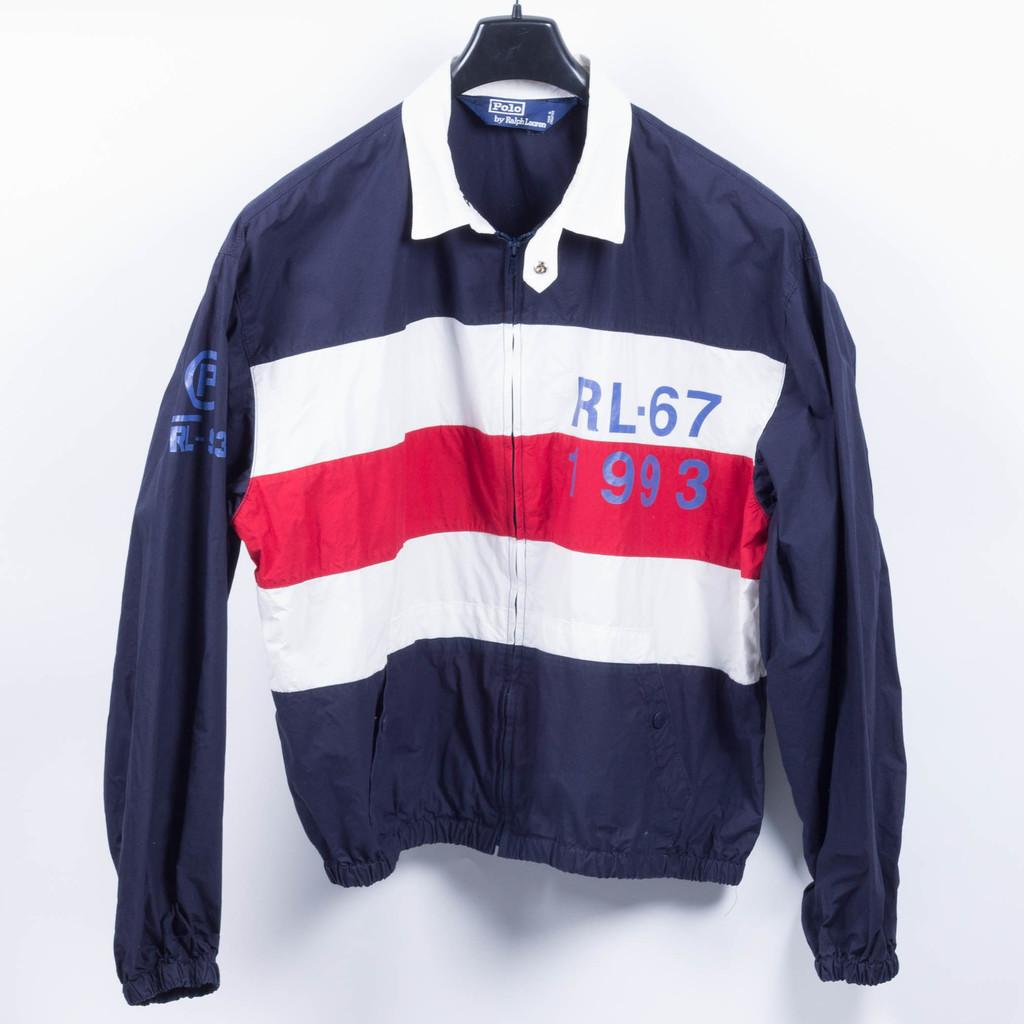<image>
Offer a succinct explanation of the picture presented. a sweatshirt that has the words RL 67 on it 